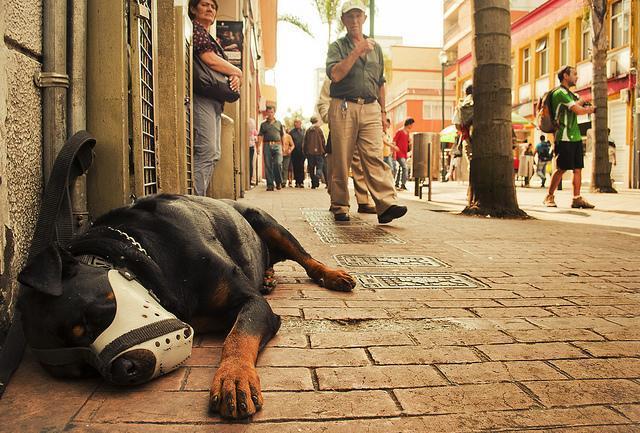How many people are there?
Give a very brief answer. 3. How many black horses are in the image?
Give a very brief answer. 0. 